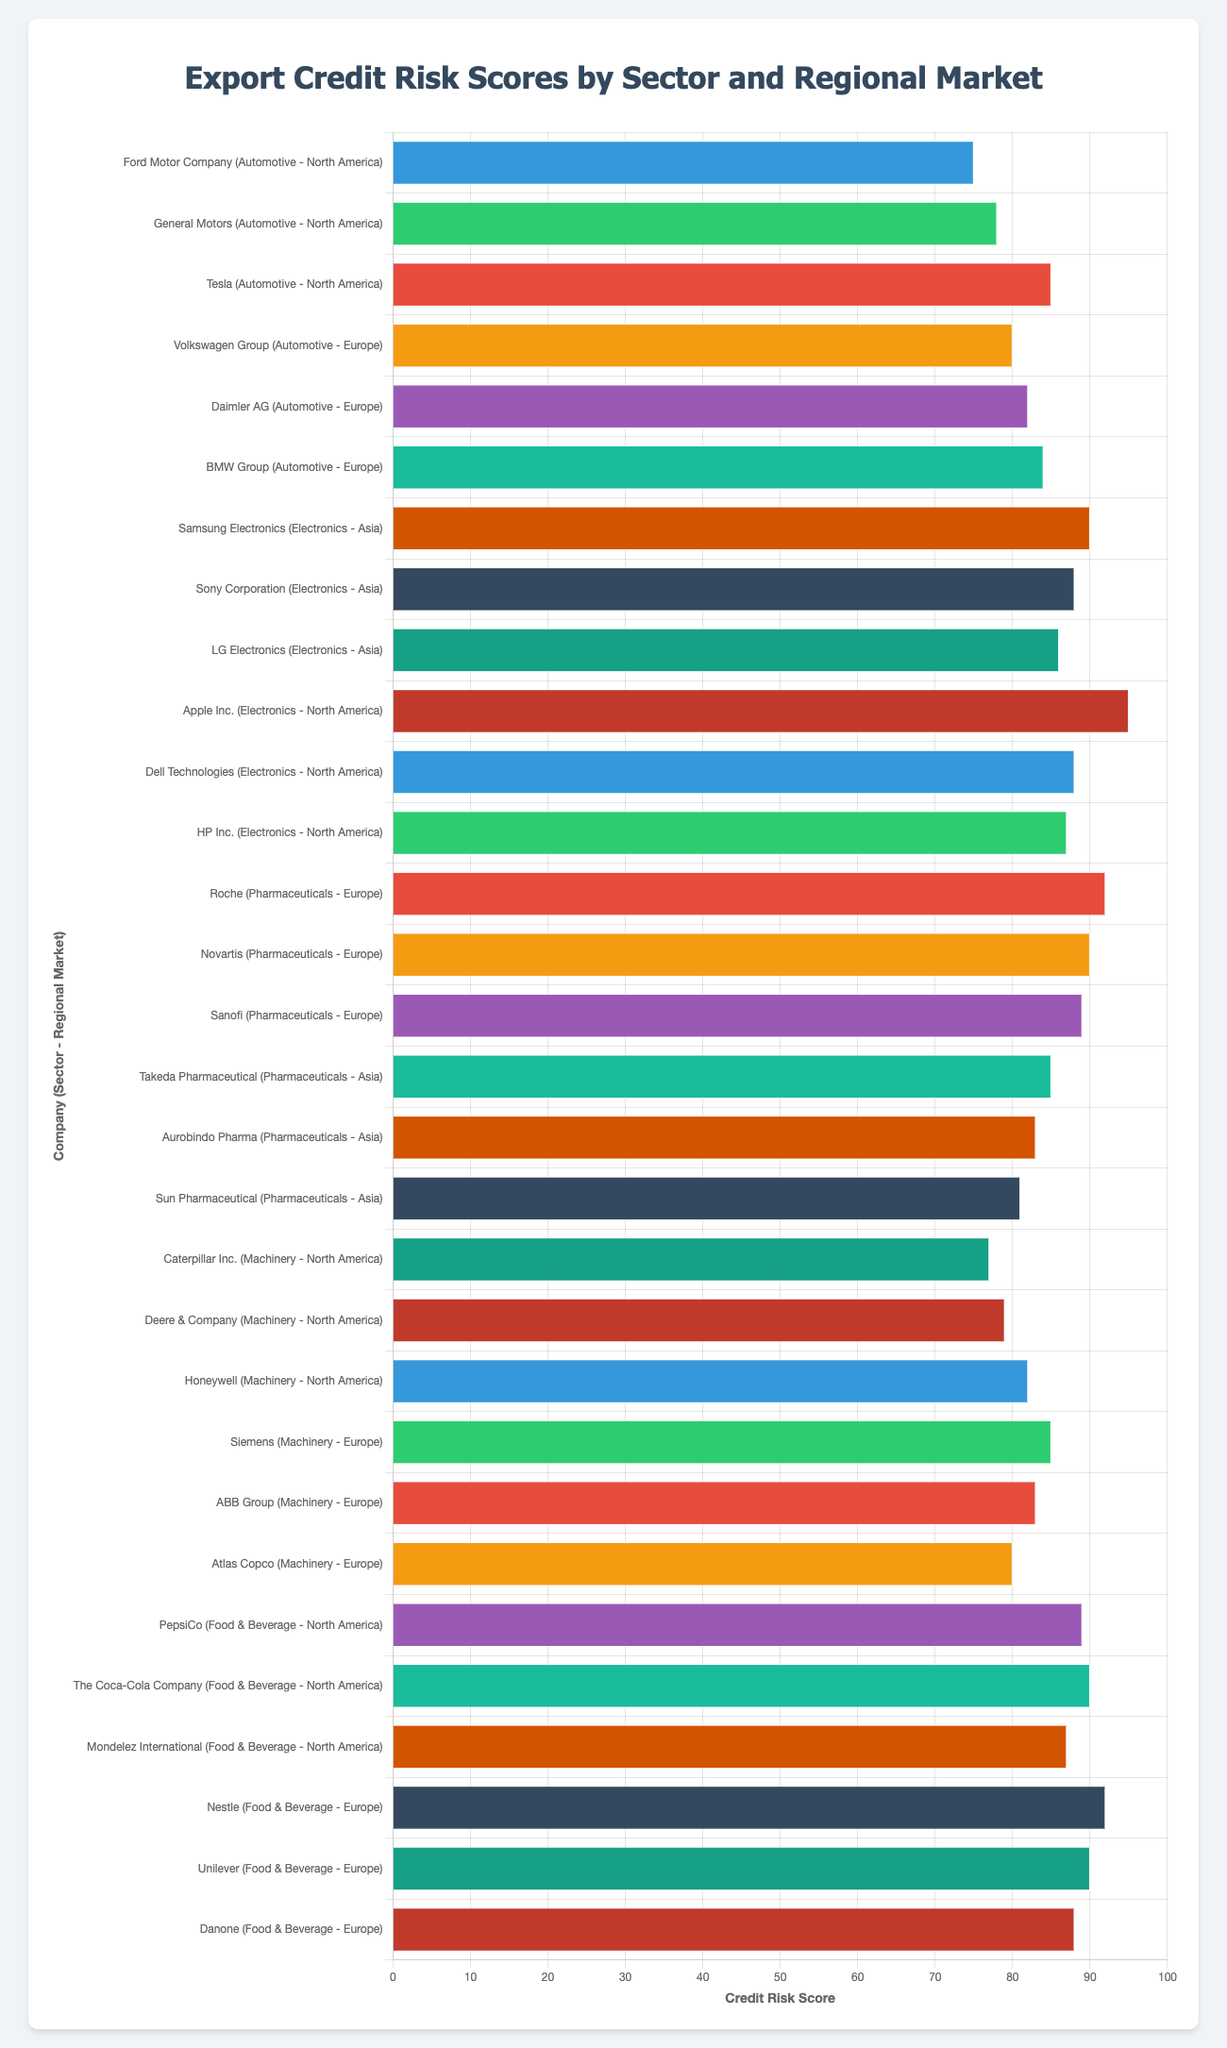Which company in the Automotive sector in North America has the highest Credit Risk Score? The figures show three companies: Ford Motor Company, General Motors, and Tesla, with Credit Risk Scores of 75, 78, and 85, respectively. Tesla's score of 85 is the highest.
Answer: Tesla Among the Electronics companies in North America, what is the average Credit Risk Score? The companies are Apple Inc. (95), Dell Technologies (88), and HP Inc. (87). Their sum is 95 + 88 + 87 = 270. The average is 270 / 3 = 90.
Answer: 90 Compare and identify which sector, between Machinery in North America and Pharmaceuticals in Asia, has a higher maximum Credit Risk Score. The Machinery companies in North America have scores of 77, 79, and 82. The Pharmaceuticals companies in Asia have scores of 85, 83, and 81. The highest score for Machinery is 82, and for Pharmaceuticals, it is 85. Thus, Pharmaceuticals in Asia has a higher maximum score.
Answer: Pharmaceuticals in Asia Which sector in Europe has companies with the highest overall Credit Risk Scores? The sectors in Europe are Automotive and Pharmaceuticals. Auto companies: Volkswagen Group (80), Daimler AG (82), BMW Group (84); highest score is 84. Pharmaceutical companies: Roche (92), Novartis (90), Sanofi (89); highest score is 92. So, pharmaceuticals in Europe have the highest overall scores.
Answer: Pharmaceuticals What is the difference between the highest Credit Risk Score in the Electronics sector in Asia and the lowest in the Automotive sector in North America? The highest Electronics score in Asia is Samsung Electronics with 90. The lowest Automotive score in North America is Ford Motor Company with 75. The difference is 90 - 75 = 15.
Answer: 15 What are the three companies with the top three highest Credit Risk Scores overall? By visually examining the length of the bars, the three companies with the highest scores are Apple Inc. (95), Roche (92), and Nestle (92).
Answer: Apple Inc., Roche, Nestle Which company has the highest Credit Risk Score in the Food & Beverage sector in North America? Comparing the scores for PepsiCo (89), The Coca-Cola Company (90), and Mondelez International (87), The Coca-Cola Company has the highest score.
Answer: The Coca-Cola Company What is the total Credit Risk Score for the companies in the Machinery sector in Europe? The companies are Siemens (85), ABB Group (83), and Atlas Copco (80). The total score is 85 + 83 + 80 = 248.
Answer: 248 Rank the top three Electronics companies in Asia by their Credit Risk Scores from highest to lowest. The companies are Samsung Electronics (90), Sony Corporation (88), and LG Electronics (86). Ranking them from highest to lowest, it goes: Samsung Electronics, Sony Corporation, LG Electronics.
Answer: Samsung Electronics, Sony Corporation, LG Electronics 